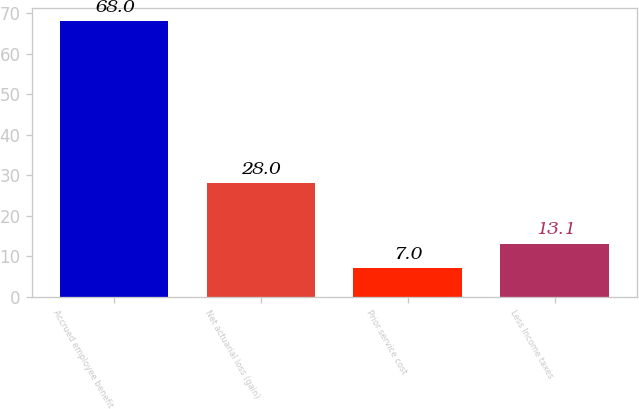Convert chart to OTSL. <chart><loc_0><loc_0><loc_500><loc_500><bar_chart><fcel>Accrued employee benefit<fcel>Net actuarial loss (gain)<fcel>Prior service cost<fcel>Less Income taxes<nl><fcel>68<fcel>28<fcel>7<fcel>13.1<nl></chart> 